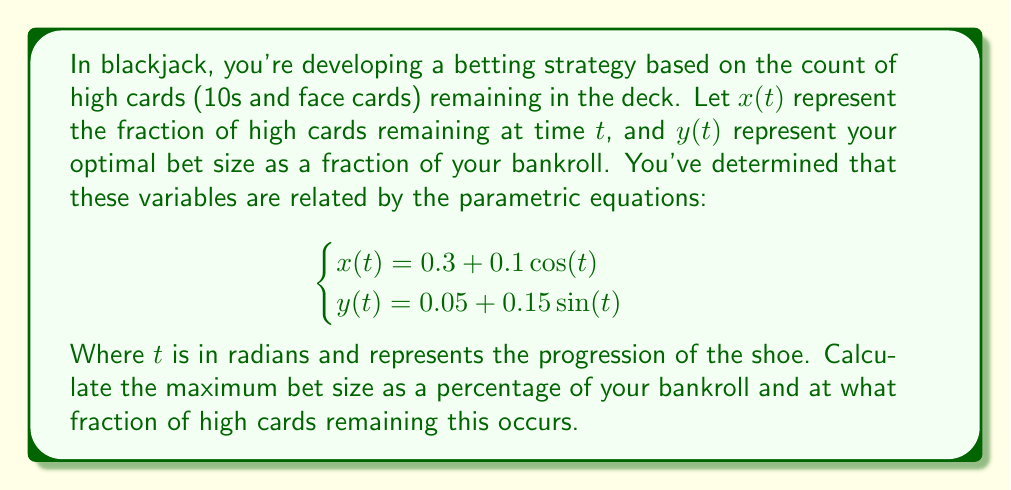Provide a solution to this math problem. To solve this problem, we need to find the maximum value of $y(t)$ and the corresponding value of $x(t)$. Let's approach this step-by-step:

1) The maximum value of $y(t)$ will occur when $\sin(t)$ is at its maximum, which is 1. This happens when $t = \frac{\pi}{2}$ (or 90 degrees).

2) At this point, $y(t)$ will be:
   $y(\frac{\pi}{2}) = 0.05 + 0.15\sin(\frac{\pi}{2}) = 0.05 + 0.15 = 0.2$

3) This means the maximum bet size is 20% of your bankroll.

4) To find the corresponding fraction of high cards remaining, we need to calculate $x(\frac{\pi}{2})$:
   $x(\frac{\pi}{2}) = 0.3 + 0.1\cos(\frac{\pi}{2}) = 0.3 + 0.1(0) = 0.3$

5) Therefore, the maximum bet occurs when 30% of high cards remain in the deck.

This strategy suggests betting the most when the deck composition is neutral (30% high cards is close to the standard deck composition of 31% high cards), which aligns with the "hard truth" that card counting provides only a marginal edge in blackjack.
Answer: The maximum bet size is 20% of the bankroll, occurring when 30% of high cards remain in the deck. 